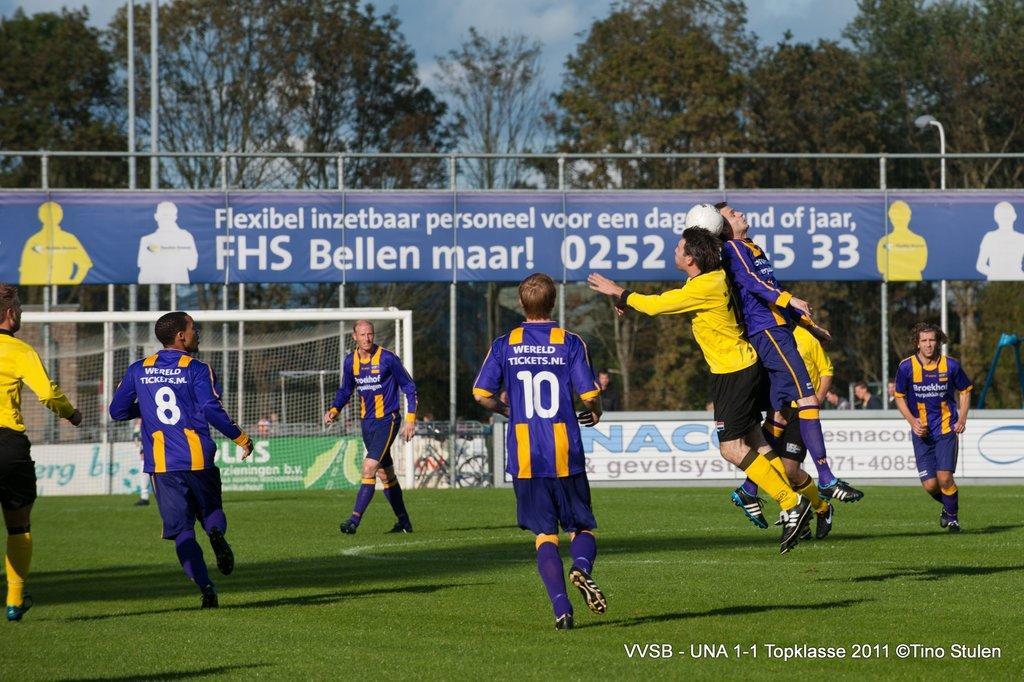Please provide a concise description of this image. In the image there are few men walking and running on the grass field playing football, in the back there is goal post on the left side with a banner above it and in the background there are trees and above its sky with clouds. 